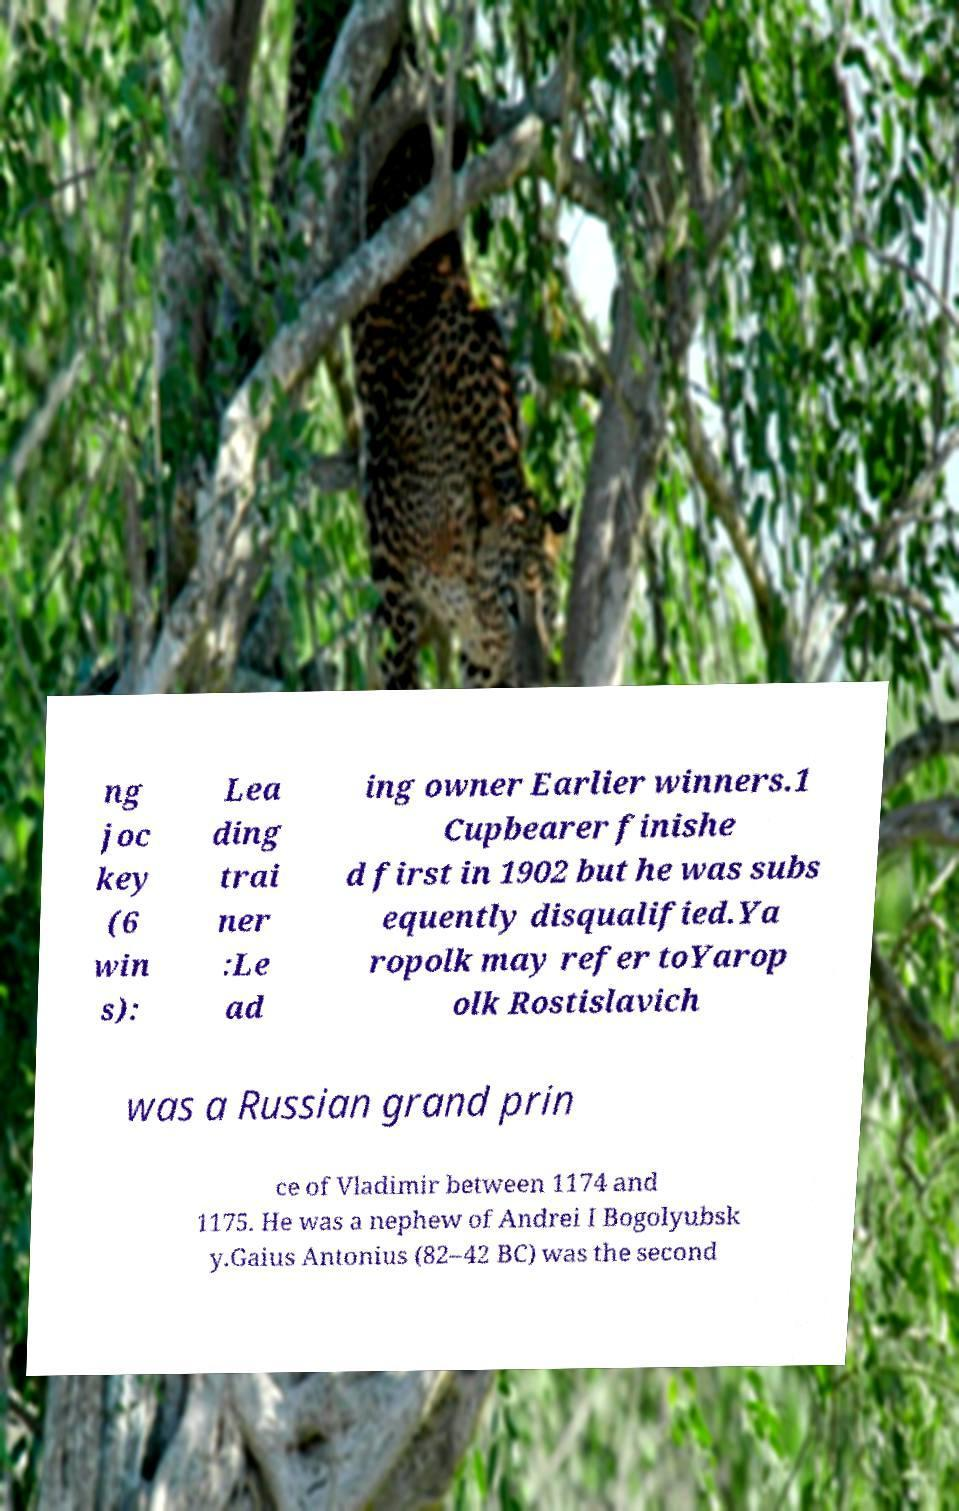Please read and relay the text visible in this image. What does it say? ng joc key (6 win s): Lea ding trai ner :Le ad ing owner Earlier winners.1 Cupbearer finishe d first in 1902 but he was subs equently disqualified.Ya ropolk may refer toYarop olk Rostislavich was a Russian grand prin ce of Vladimir between 1174 and 1175. He was a nephew of Andrei I Bogolyubsk y.Gaius Antonius (82–42 BC) was the second 